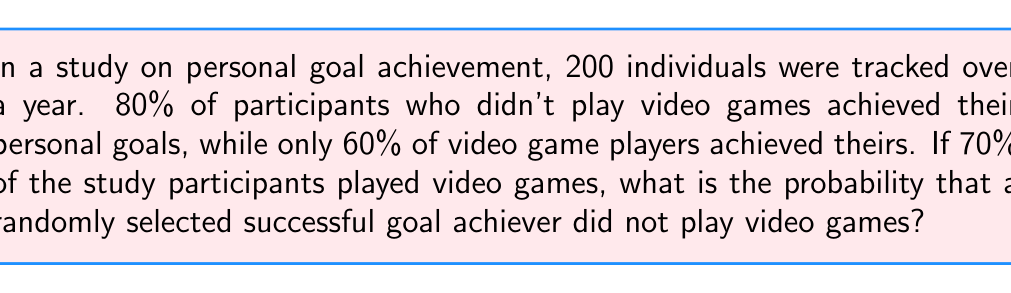Could you help me with this problem? Let's approach this step-by-step using Bayes' theorem:

1) Define events:
   A: Achieved personal goals
   B: Did not play video games

2) Given information:
   P(B) = 1 - 0.70 = 0.30 (probability of not playing video games)
   P(A|B) = 0.80 (probability of achieving goals given not playing video games)
   P(A|not B) = 0.60 (probability of achieving goals given playing video games)

3) We need to find P(B|A) using Bayes' theorem:

   $$P(B|A) = \frac{P(A|B) \cdot P(B)}{P(A)}$$

4) Calculate P(A) using the law of total probability:
   $$P(A) = P(A|B) \cdot P(B) + P(A|not B) \cdot P(not B)$$
   $$P(A) = 0.80 \cdot 0.30 + 0.60 \cdot 0.70 = 0.24 + 0.42 = 0.66$$

5) Now we can apply Bayes' theorem:

   $$P(B|A) = \frac{0.80 \cdot 0.30}{0.66} = \frac{0.24}{0.66} = \frac{4}{11} \approx 0.3636$$
Answer: $\frac{4}{11}$ or approximately 0.3636 